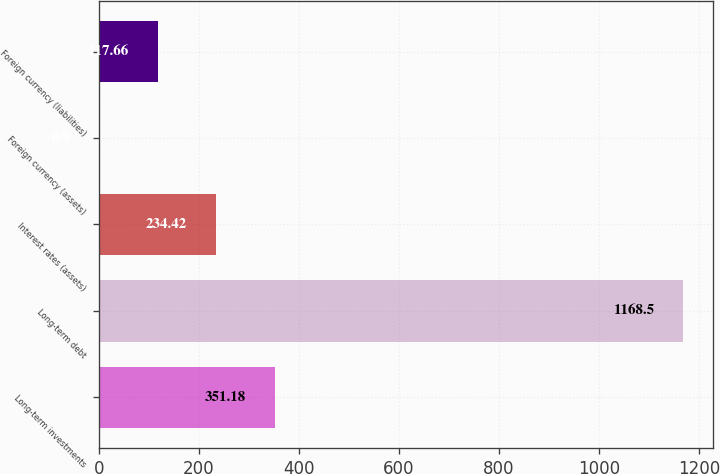Convert chart to OTSL. <chart><loc_0><loc_0><loc_500><loc_500><bar_chart><fcel>Long-term investments<fcel>Long-term debt<fcel>Interest rates (assets)<fcel>Foreign currency (assets)<fcel>Foreign currency (liabilities)<nl><fcel>351.18<fcel>1168.5<fcel>234.42<fcel>0.9<fcel>117.66<nl></chart> 